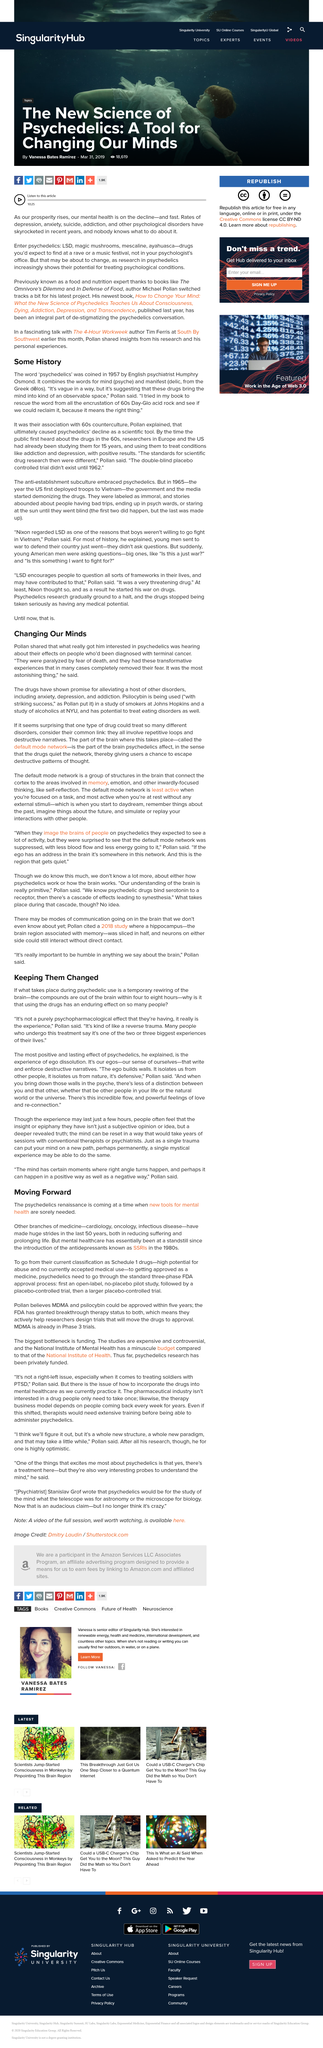Point out several critical features in this image. The study of smokers and psilocybin use was conducted at Johns Hopkins. Researchers had been studying psychedelics for 15 years before they first became known to the public in the 1960s. The study of alcoholics and psilocybin use was conducted at NYU. The compounds are rapidly eliminated from the brain within a four to eight hour time frame," said the researchers. Yes, the temporary rewiring of the brain that takes place during psychedelic use is similar to a reverse trauma. 